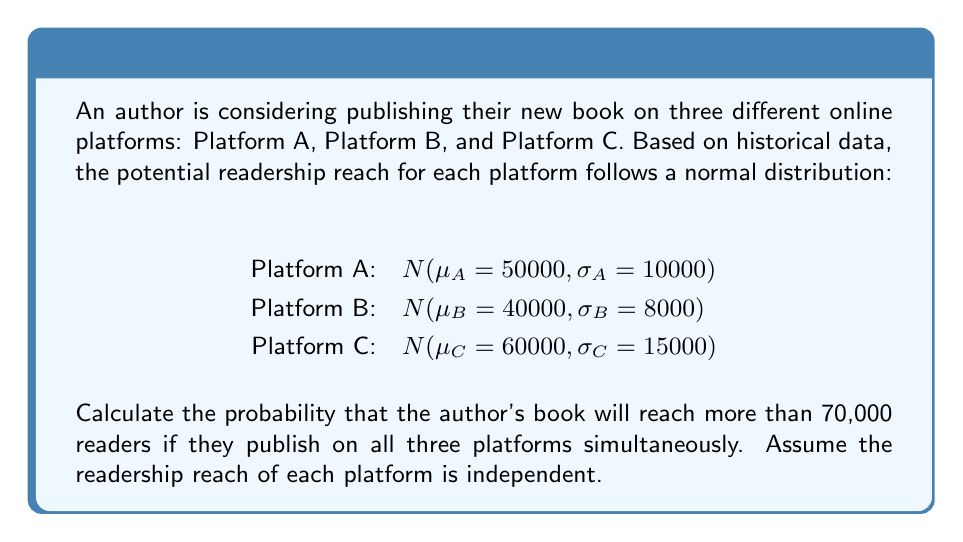Teach me how to tackle this problem. To solve this problem, we need to follow these steps:

1) First, we need to calculate the total readership distribution when publishing on all three platforms simultaneously. Since the platforms are independent, we can add their means and variances:

   $\mu_{total} = \mu_A + \mu_B + \mu_C = 50000 + 40000 + 60000 = 150000$
   $\sigma^2_{total} = \sigma^2_A + \sigma^2_B + \sigma^2_C = 10000^2 + 8000^2 + 15000^2 = 389000000$
   $\sigma_{total} = \sqrt{389000000} \approx 19723$

2) The total readership distribution is therefore $N(150000, 19723)$.

3) We want to find $P(X > 70000)$ where $X$ is the total readership.

4) To standardize this, we calculate the z-score:

   $z = \frac{70000 - 150000}{19723} \approx -4.06$

5) We need to find $P(Z > -4.06)$ where $Z$ is the standard normal distribution.

6) Using a standard normal table or calculator, we find:

   $P(Z > -4.06) = 1 - P(Z < -4.06) \approx 1 - 0.0000248 = 0.9999752$

Therefore, the probability of reaching more than 70,000 readers is approximately 0.9999752 or 99.99752%.
Answer: The probability that the author's book will reach more than 70,000 readers if published on all three platforms simultaneously is approximately 0.9999752 or 99.99752%. 